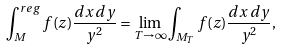<formula> <loc_0><loc_0><loc_500><loc_500>\int ^ { r e g } _ { M } f ( z ) \frac { d x \, d y } { y ^ { 2 } } = \lim _ { T \to \infty } \int _ { M _ { T } } f ( z ) \frac { d x \, d y } { y ^ { 2 } } ,</formula> 